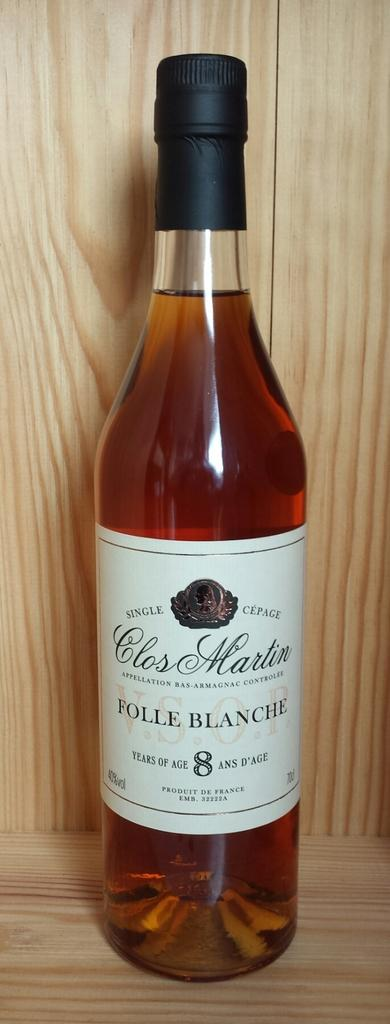<image>
Relay a brief, clear account of the picture shown. A bottle of Folle Blanche stands in its wooden presentation box. 